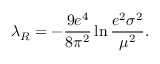Convert formula to latex. <formula><loc_0><loc_0><loc_500><loc_500>\lambda _ { R } = - \frac { 9 e ^ { 4 } } { 8 \pi ^ { 2 } } \ln \frac { e ^ { 2 } \sigma ^ { 2 } } { \mu ^ { 2 } } .</formula> 